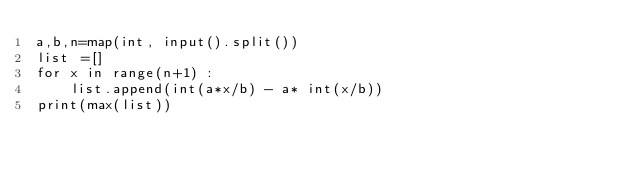<code> <loc_0><loc_0><loc_500><loc_500><_Python_>a,b,n=map(int, input().split())
list =[]
for x in range(n+1) :
    list.append(int(a*x/b) - a* int(x/b))
print(max(list))</code> 